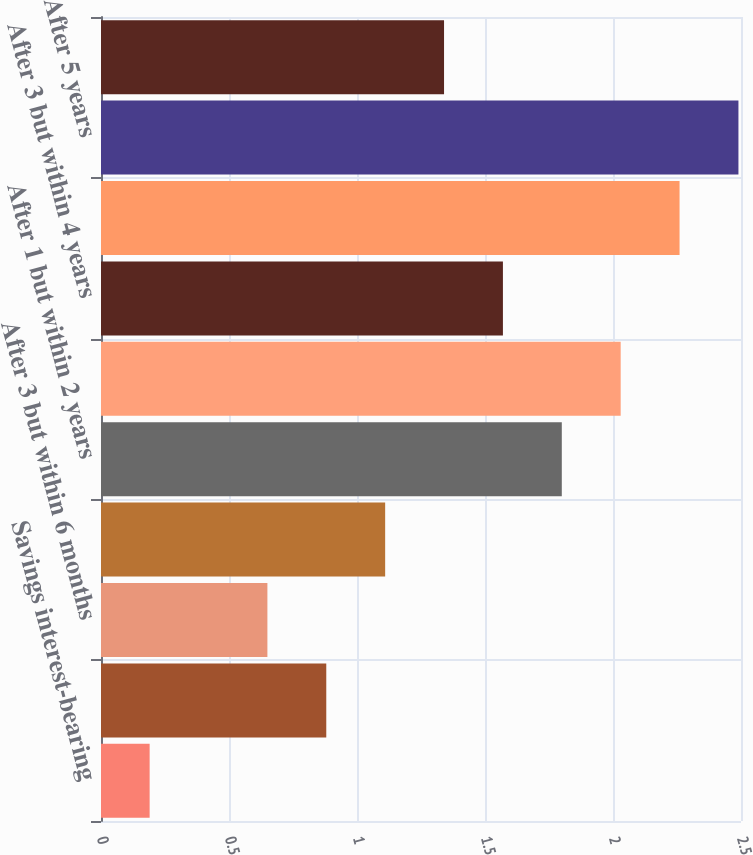Convert chart to OTSL. <chart><loc_0><loc_0><loc_500><loc_500><bar_chart><fcel>Savings interest-bearing<fcel>Within 3 months<fcel>After 3 but within 6 months<fcel>After 6 months but within 1<fcel>After 1 but within 2 years<fcel>After 2 but within 3 years<fcel>After 3 but within 4 years<fcel>After 4 but within 5 years<fcel>After 5 years<fcel>Total<nl><fcel>0.19<fcel>0.88<fcel>0.65<fcel>1.11<fcel>1.8<fcel>2.03<fcel>1.57<fcel>2.26<fcel>2.49<fcel>1.34<nl></chart> 